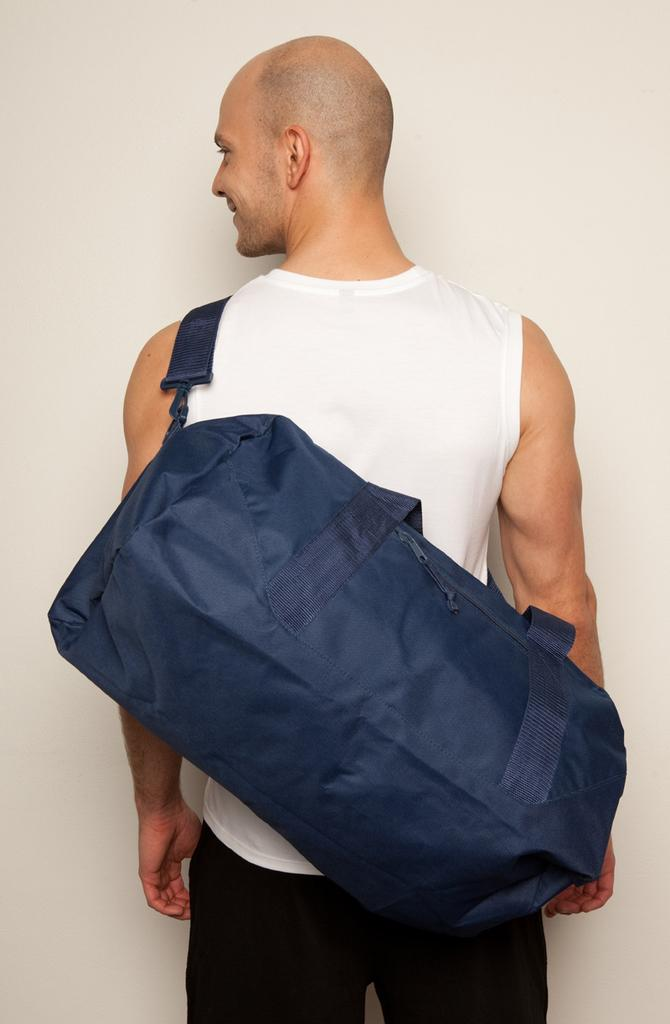Who is present in the image? There is a man in the image. What is the man wearing on his upper body? The man is wearing a white tank top. What is the man wearing on his lower body? The man is wearing black pants. What is the man carrying in the image? The man is carrying a blue bag. What color is the background of the image? The background of the image is white. How many flowers can be seen in the image? There are no flowers present in the image. What type of boundary is visible in the image? There is no boundary visible in the image. 